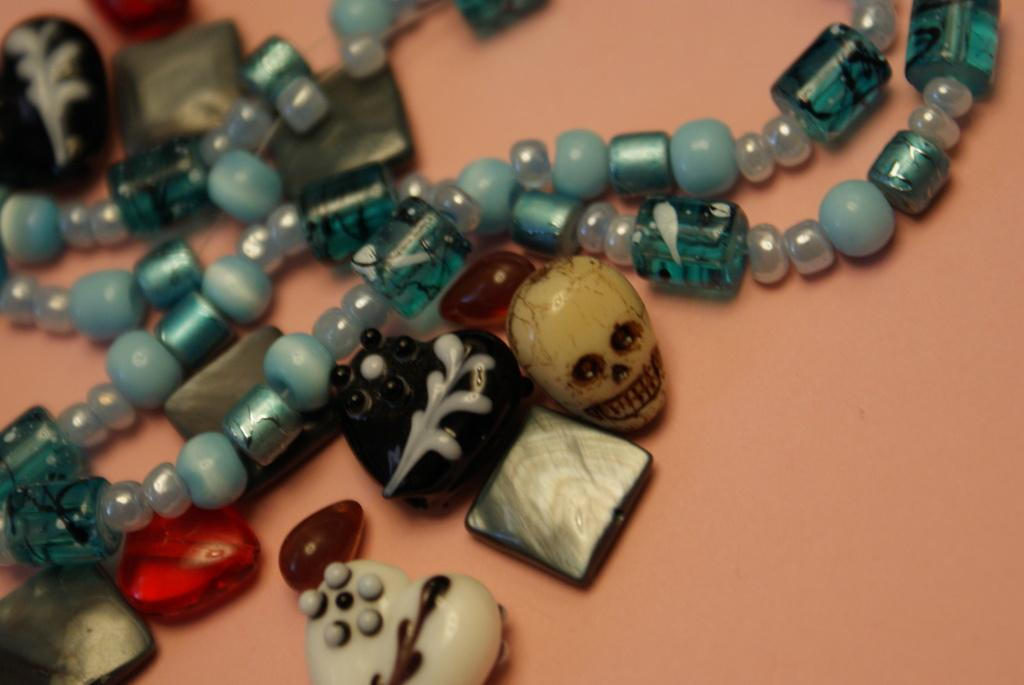What type of items can be seen in the image? The image contains artificial jewelry. Can you describe the jewelry in more detail? Unfortunately, the image does not provide enough detail to describe the jewelry further. What type of drink is being served in the image? There is no drink present in the image; it only contains artificial jewelry. Can you see any seeds or plants in the image? No, there are no seeds or plants visible in the image. 